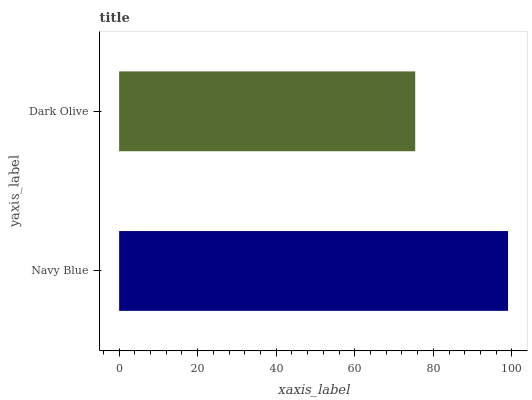Is Dark Olive the minimum?
Answer yes or no. Yes. Is Navy Blue the maximum?
Answer yes or no. Yes. Is Dark Olive the maximum?
Answer yes or no. No. Is Navy Blue greater than Dark Olive?
Answer yes or no. Yes. Is Dark Olive less than Navy Blue?
Answer yes or no. Yes. Is Dark Olive greater than Navy Blue?
Answer yes or no. No. Is Navy Blue less than Dark Olive?
Answer yes or no. No. Is Navy Blue the high median?
Answer yes or no. Yes. Is Dark Olive the low median?
Answer yes or no. Yes. Is Dark Olive the high median?
Answer yes or no. No. Is Navy Blue the low median?
Answer yes or no. No. 